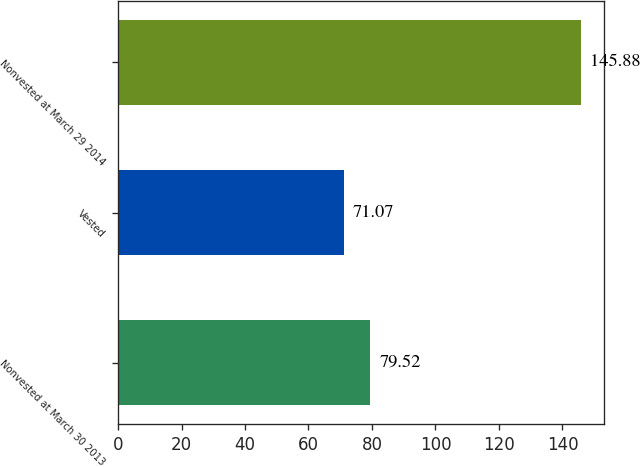<chart> <loc_0><loc_0><loc_500><loc_500><bar_chart><fcel>Nonvested at March 30 2013<fcel>Vested<fcel>Nonvested at March 29 2014<nl><fcel>79.52<fcel>71.07<fcel>145.88<nl></chart> 